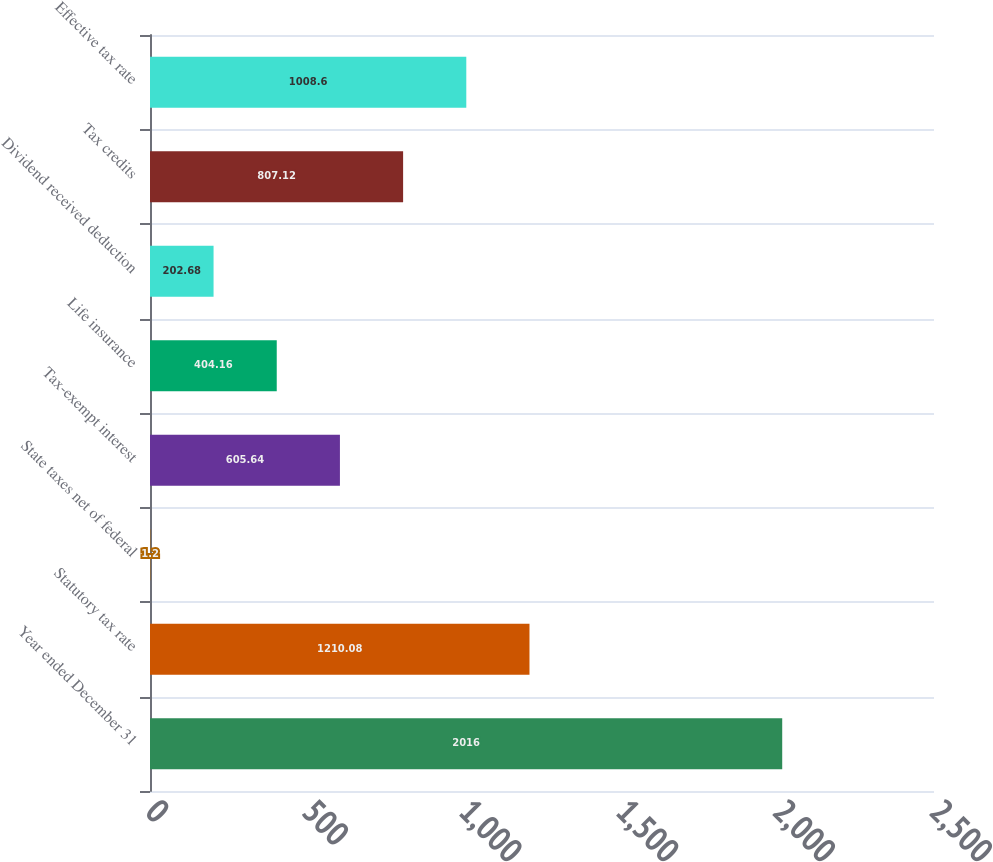Convert chart. <chart><loc_0><loc_0><loc_500><loc_500><bar_chart><fcel>Year ended December 31<fcel>Statutory tax rate<fcel>State taxes net of federal<fcel>Tax-exempt interest<fcel>Life insurance<fcel>Dividend received deduction<fcel>Tax credits<fcel>Effective tax rate<nl><fcel>2016<fcel>1210.08<fcel>1.2<fcel>605.64<fcel>404.16<fcel>202.68<fcel>807.12<fcel>1008.6<nl></chart> 